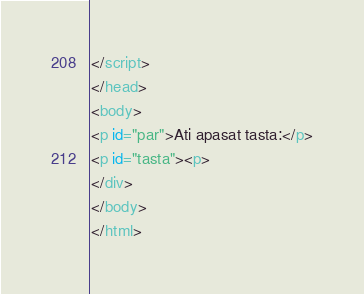Convert code to text. <code><loc_0><loc_0><loc_500><loc_500><_HTML_></script>
</head>
<body>
<p id="par">Ati apasat tasta:</p>
<p id="tasta"><p>
</div>
</body>
</html>
</code> 